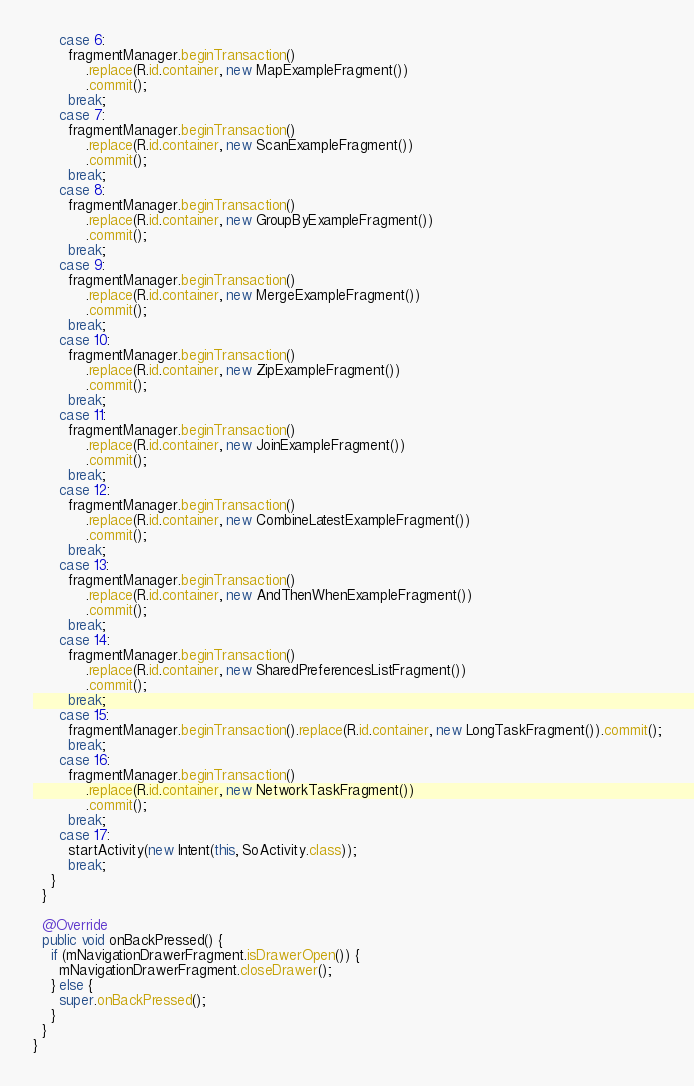Convert code to text. <code><loc_0><loc_0><loc_500><loc_500><_Java_>      case 6:
        fragmentManager.beginTransaction()
            .replace(R.id.container, new MapExampleFragment())
            .commit();
        break;
      case 7:
        fragmentManager.beginTransaction()
            .replace(R.id.container, new ScanExampleFragment())
            .commit();
        break;
      case 8:
        fragmentManager.beginTransaction()
            .replace(R.id.container, new GroupByExampleFragment())
            .commit();
        break;
      case 9:
        fragmentManager.beginTransaction()
            .replace(R.id.container, new MergeExampleFragment())
            .commit();
        break;
      case 10:
        fragmentManager.beginTransaction()
            .replace(R.id.container, new ZipExampleFragment())
            .commit();
        break;
      case 11:
        fragmentManager.beginTransaction()
            .replace(R.id.container, new JoinExampleFragment())
            .commit();
        break;
      case 12:
        fragmentManager.beginTransaction()
            .replace(R.id.container, new CombineLatestExampleFragment())
            .commit();
        break;
      case 13:
        fragmentManager.beginTransaction()
            .replace(R.id.container, new AndThenWhenExampleFragment())
            .commit();
        break;
      case 14:
        fragmentManager.beginTransaction()
            .replace(R.id.container, new SharedPreferencesListFragment())
            .commit();
        break;
      case 15:
        fragmentManager.beginTransaction().replace(R.id.container, new LongTaskFragment()).commit();
        break;
      case 16:
        fragmentManager.beginTransaction()
            .replace(R.id.container, new NetworkTaskFragment())
            .commit();
        break;
      case 17:
        startActivity(new Intent(this, SoActivity.class));
        break;
    }
  }

  @Override
  public void onBackPressed() {
    if (mNavigationDrawerFragment.isDrawerOpen()) {
      mNavigationDrawerFragment.closeDrawer();
    } else {
      super.onBackPressed();
    }
  }
}
</code> 